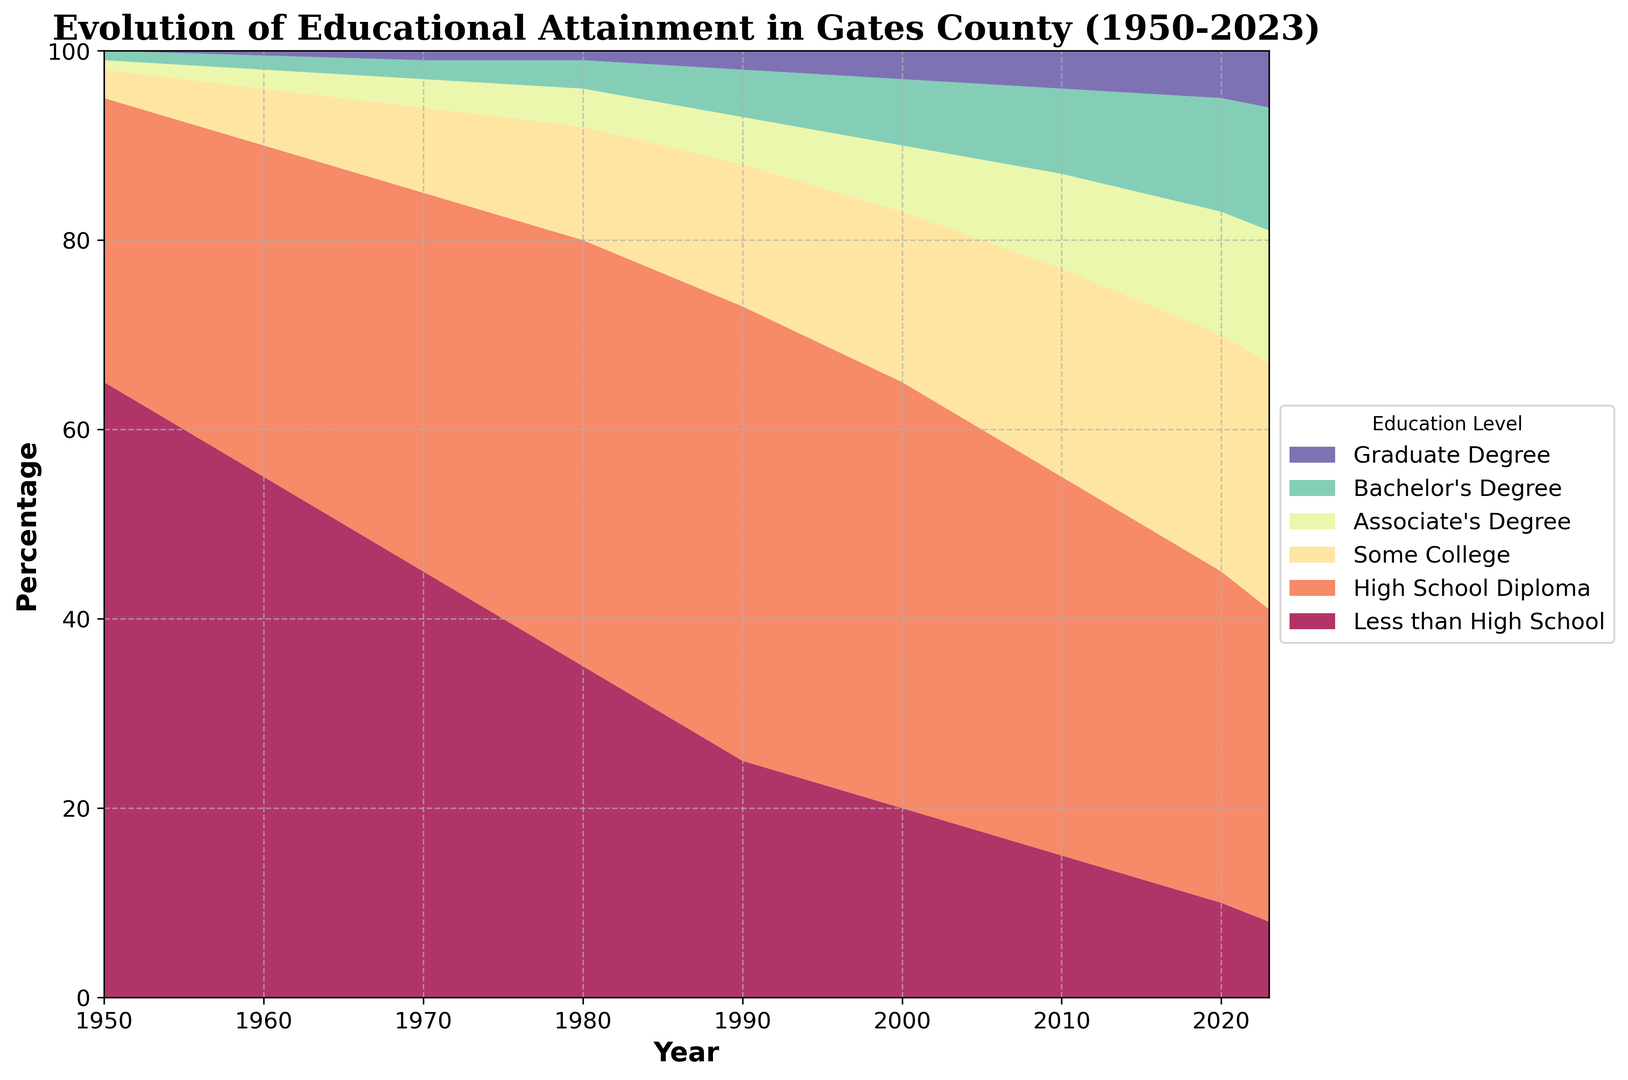What has been the trend for individuals with a High School Diploma from 1950 to 2023? From the figure, we can observe the area representing the percentage of individuals with a High School Diploma increases from 1950 onward. It peaks around 1990 and then has a slight decline but remains relatively high and stable until 2023.
Answer: Increasing trend with slight decline post-1990 Between which years did individuals with an Associate's Degree see the most significant increase? By comparing the areas representing Associate's Degree across the years, we can see the most significant increase occurs between 2010 and 2020, as the area's height noticeably grows.
Answer: 2010-2020 What proportion of the population had less than a High School education in 1950 compared to 2023? The height of the area for 'Less than High School' in 1950 is around 65%, while in 2023, it's roughly 8%. This shows a drastic reduction over the years.
Answer: 65% in 1950 and 8% in 2023 How does the percentage of individuals with a Bachelor's Degree in 2023 compare to 2000? From the figure, the area for Bachelor's Degree in 2023 is around 13%, while in 2000, it is approximately 7%. This shows an increase in the percentage of individuals with a Bachelor's Degree.
Answer: Higher in 2023 (13%) than in 2000 (7%) Which degree type showed the first significant increase after 1950? By observing the point in time when each area begins to noticeably increase, 'High School Diploma' shows the first significant increase, starting around 1950-1960.
Answer: High School Diploma Did the percentage of individuals with Graduate Degrees ever surpass 10% between 1950 to 2023? By examining the figure, although there is growth in the Graduate Degree category, its area never surpasses the 10% mark at any point from 1950 to 2023.
Answer: No Which degree type had the highest growth rate in the last decade, from 2010 to 2023? By comparing the steepness of the areas in this period, 'Bachelor's Degree' has the steepest increase, suggesting the highest growth rate.
Answer: Bachelor's Degree In what year did the 'Some College' category first exceed 20%? The area for 'Some College' exceeds the 20% mark around the year 2010, as observed by the height of its area.
Answer: 2010 What is the sum of the percentage for individuals with an Associate's Degree and Bachelor's Degree in 2023? The area for Associate's Degree in 2023 is approximately 14%, and for Bachelor's Degree, it is around 13%. Summing these gives 14% + 13% = 27%.
Answer: 27% 